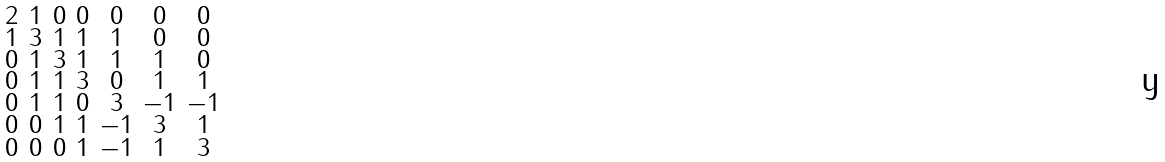Convert formula to latex. <formula><loc_0><loc_0><loc_500><loc_500>\begin{smallmatrix} 2 & 1 & 0 & 0 & 0 & 0 & 0 \\ 1 & 3 & 1 & 1 & 1 & 0 & 0 \\ 0 & 1 & 3 & 1 & 1 & 1 & 0 \\ 0 & 1 & 1 & 3 & 0 & 1 & 1 \\ 0 & 1 & 1 & 0 & 3 & - 1 & - 1 \\ 0 & 0 & 1 & 1 & - 1 & 3 & 1 \\ 0 & 0 & 0 & 1 & - 1 & 1 & 3 \end{smallmatrix}</formula> 